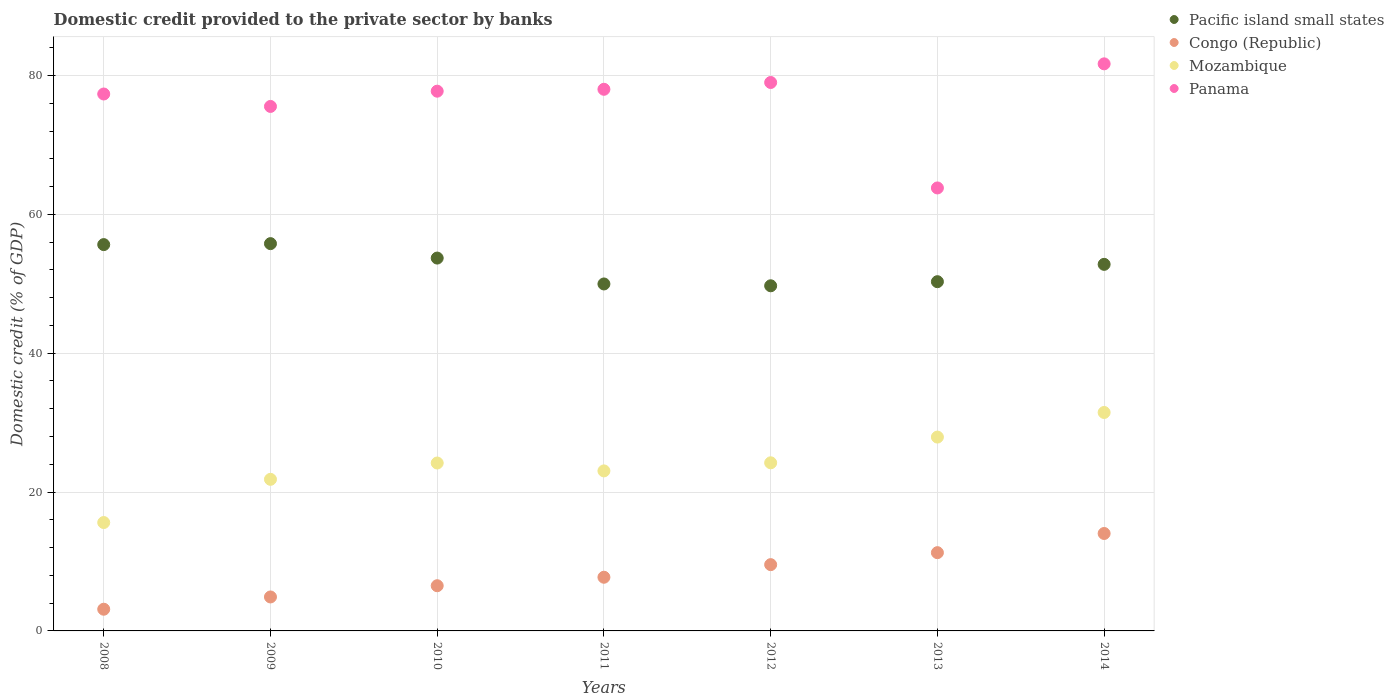How many different coloured dotlines are there?
Provide a short and direct response. 4. Is the number of dotlines equal to the number of legend labels?
Your response must be concise. Yes. What is the domestic credit provided to the private sector by banks in Congo (Republic) in 2010?
Your answer should be very brief. 6.51. Across all years, what is the maximum domestic credit provided to the private sector by banks in Congo (Republic)?
Your answer should be very brief. 14.03. Across all years, what is the minimum domestic credit provided to the private sector by banks in Congo (Republic)?
Your answer should be compact. 3.13. In which year was the domestic credit provided to the private sector by banks in Congo (Republic) maximum?
Offer a very short reply. 2014. In which year was the domestic credit provided to the private sector by banks in Mozambique minimum?
Offer a terse response. 2008. What is the total domestic credit provided to the private sector by banks in Pacific island small states in the graph?
Your answer should be very brief. 367.88. What is the difference between the domestic credit provided to the private sector by banks in Mozambique in 2010 and that in 2013?
Provide a short and direct response. -3.74. What is the difference between the domestic credit provided to the private sector by banks in Panama in 2013 and the domestic credit provided to the private sector by banks in Mozambique in 2008?
Your answer should be compact. 48.19. What is the average domestic credit provided to the private sector by banks in Congo (Republic) per year?
Your answer should be compact. 8.16. In the year 2014, what is the difference between the domestic credit provided to the private sector by banks in Congo (Republic) and domestic credit provided to the private sector by banks in Pacific island small states?
Keep it short and to the point. -38.76. In how many years, is the domestic credit provided to the private sector by banks in Panama greater than 12 %?
Keep it short and to the point. 7. What is the ratio of the domestic credit provided to the private sector by banks in Congo (Republic) in 2010 to that in 2013?
Keep it short and to the point. 0.58. What is the difference between the highest and the second highest domestic credit provided to the private sector by banks in Congo (Republic)?
Offer a terse response. 2.76. What is the difference between the highest and the lowest domestic credit provided to the private sector by banks in Congo (Republic)?
Offer a terse response. 10.91. In how many years, is the domestic credit provided to the private sector by banks in Congo (Republic) greater than the average domestic credit provided to the private sector by banks in Congo (Republic) taken over all years?
Offer a terse response. 3. Is the sum of the domestic credit provided to the private sector by banks in Mozambique in 2011 and 2013 greater than the maximum domestic credit provided to the private sector by banks in Panama across all years?
Keep it short and to the point. No. Is it the case that in every year, the sum of the domestic credit provided to the private sector by banks in Congo (Republic) and domestic credit provided to the private sector by banks in Panama  is greater than the sum of domestic credit provided to the private sector by banks in Pacific island small states and domestic credit provided to the private sector by banks in Mozambique?
Give a very brief answer. No. Does the domestic credit provided to the private sector by banks in Pacific island small states monotonically increase over the years?
Offer a very short reply. No. What is the difference between two consecutive major ticks on the Y-axis?
Provide a short and direct response. 20. Are the values on the major ticks of Y-axis written in scientific E-notation?
Your response must be concise. No. Does the graph contain any zero values?
Provide a short and direct response. No. How are the legend labels stacked?
Ensure brevity in your answer.  Vertical. What is the title of the graph?
Give a very brief answer. Domestic credit provided to the private sector by banks. What is the label or title of the Y-axis?
Provide a succinct answer. Domestic credit (% of GDP). What is the Domestic credit (% of GDP) in Pacific island small states in 2008?
Provide a short and direct response. 55.64. What is the Domestic credit (% of GDP) in Congo (Republic) in 2008?
Offer a very short reply. 3.13. What is the Domestic credit (% of GDP) of Mozambique in 2008?
Keep it short and to the point. 15.61. What is the Domestic credit (% of GDP) in Panama in 2008?
Offer a very short reply. 77.33. What is the Domestic credit (% of GDP) of Pacific island small states in 2009?
Give a very brief answer. 55.78. What is the Domestic credit (% of GDP) in Congo (Republic) in 2009?
Provide a succinct answer. 4.89. What is the Domestic credit (% of GDP) of Mozambique in 2009?
Provide a succinct answer. 21.83. What is the Domestic credit (% of GDP) in Panama in 2009?
Your answer should be compact. 75.54. What is the Domestic credit (% of GDP) of Pacific island small states in 2010?
Your answer should be very brief. 53.7. What is the Domestic credit (% of GDP) in Congo (Republic) in 2010?
Your answer should be very brief. 6.51. What is the Domestic credit (% of GDP) in Mozambique in 2010?
Provide a succinct answer. 24.18. What is the Domestic credit (% of GDP) of Panama in 2010?
Make the answer very short. 77.74. What is the Domestic credit (% of GDP) of Pacific island small states in 2011?
Make the answer very short. 49.97. What is the Domestic credit (% of GDP) in Congo (Republic) in 2011?
Your answer should be very brief. 7.73. What is the Domestic credit (% of GDP) of Mozambique in 2011?
Ensure brevity in your answer.  23.05. What is the Domestic credit (% of GDP) in Panama in 2011?
Offer a very short reply. 78.01. What is the Domestic credit (% of GDP) in Pacific island small states in 2012?
Your answer should be very brief. 49.71. What is the Domestic credit (% of GDP) of Congo (Republic) in 2012?
Ensure brevity in your answer.  9.54. What is the Domestic credit (% of GDP) in Mozambique in 2012?
Provide a short and direct response. 24.21. What is the Domestic credit (% of GDP) of Panama in 2012?
Offer a terse response. 78.99. What is the Domestic credit (% of GDP) of Pacific island small states in 2013?
Make the answer very short. 50.3. What is the Domestic credit (% of GDP) in Congo (Republic) in 2013?
Your answer should be very brief. 11.27. What is the Domestic credit (% of GDP) of Mozambique in 2013?
Provide a succinct answer. 27.92. What is the Domestic credit (% of GDP) in Panama in 2013?
Provide a short and direct response. 63.8. What is the Domestic credit (% of GDP) in Pacific island small states in 2014?
Your answer should be very brief. 52.79. What is the Domestic credit (% of GDP) of Congo (Republic) in 2014?
Make the answer very short. 14.03. What is the Domestic credit (% of GDP) of Mozambique in 2014?
Keep it short and to the point. 31.46. What is the Domestic credit (% of GDP) of Panama in 2014?
Your answer should be very brief. 81.67. Across all years, what is the maximum Domestic credit (% of GDP) of Pacific island small states?
Your answer should be very brief. 55.78. Across all years, what is the maximum Domestic credit (% of GDP) of Congo (Republic)?
Offer a very short reply. 14.03. Across all years, what is the maximum Domestic credit (% of GDP) of Mozambique?
Offer a very short reply. 31.46. Across all years, what is the maximum Domestic credit (% of GDP) of Panama?
Your answer should be very brief. 81.67. Across all years, what is the minimum Domestic credit (% of GDP) in Pacific island small states?
Ensure brevity in your answer.  49.71. Across all years, what is the minimum Domestic credit (% of GDP) of Congo (Republic)?
Give a very brief answer. 3.13. Across all years, what is the minimum Domestic credit (% of GDP) in Mozambique?
Offer a terse response. 15.61. Across all years, what is the minimum Domestic credit (% of GDP) in Panama?
Give a very brief answer. 63.8. What is the total Domestic credit (% of GDP) in Pacific island small states in the graph?
Your response must be concise. 367.88. What is the total Domestic credit (% of GDP) in Congo (Republic) in the graph?
Your answer should be very brief. 57.11. What is the total Domestic credit (% of GDP) in Mozambique in the graph?
Your response must be concise. 168.26. What is the total Domestic credit (% of GDP) of Panama in the graph?
Ensure brevity in your answer.  533.07. What is the difference between the Domestic credit (% of GDP) in Pacific island small states in 2008 and that in 2009?
Offer a terse response. -0.14. What is the difference between the Domestic credit (% of GDP) in Congo (Republic) in 2008 and that in 2009?
Provide a succinct answer. -1.77. What is the difference between the Domestic credit (% of GDP) of Mozambique in 2008 and that in 2009?
Give a very brief answer. -6.22. What is the difference between the Domestic credit (% of GDP) of Panama in 2008 and that in 2009?
Ensure brevity in your answer.  1.79. What is the difference between the Domestic credit (% of GDP) of Pacific island small states in 2008 and that in 2010?
Ensure brevity in your answer.  1.94. What is the difference between the Domestic credit (% of GDP) in Congo (Republic) in 2008 and that in 2010?
Offer a terse response. -3.38. What is the difference between the Domestic credit (% of GDP) of Mozambique in 2008 and that in 2010?
Keep it short and to the point. -8.57. What is the difference between the Domestic credit (% of GDP) in Panama in 2008 and that in 2010?
Provide a short and direct response. -0.41. What is the difference between the Domestic credit (% of GDP) in Pacific island small states in 2008 and that in 2011?
Offer a very short reply. 5.67. What is the difference between the Domestic credit (% of GDP) in Congo (Republic) in 2008 and that in 2011?
Your answer should be compact. -4.61. What is the difference between the Domestic credit (% of GDP) in Mozambique in 2008 and that in 2011?
Your answer should be compact. -7.44. What is the difference between the Domestic credit (% of GDP) of Panama in 2008 and that in 2011?
Your answer should be compact. -0.68. What is the difference between the Domestic credit (% of GDP) of Pacific island small states in 2008 and that in 2012?
Provide a short and direct response. 5.93. What is the difference between the Domestic credit (% of GDP) in Congo (Republic) in 2008 and that in 2012?
Ensure brevity in your answer.  -6.42. What is the difference between the Domestic credit (% of GDP) of Mozambique in 2008 and that in 2012?
Your answer should be very brief. -8.6. What is the difference between the Domestic credit (% of GDP) of Panama in 2008 and that in 2012?
Provide a succinct answer. -1.66. What is the difference between the Domestic credit (% of GDP) in Pacific island small states in 2008 and that in 2013?
Your answer should be very brief. 5.34. What is the difference between the Domestic credit (% of GDP) of Congo (Republic) in 2008 and that in 2013?
Offer a very short reply. -8.15. What is the difference between the Domestic credit (% of GDP) in Mozambique in 2008 and that in 2013?
Provide a short and direct response. -12.31. What is the difference between the Domestic credit (% of GDP) in Panama in 2008 and that in 2013?
Keep it short and to the point. 13.53. What is the difference between the Domestic credit (% of GDP) of Pacific island small states in 2008 and that in 2014?
Give a very brief answer. 2.84. What is the difference between the Domestic credit (% of GDP) in Congo (Republic) in 2008 and that in 2014?
Give a very brief answer. -10.91. What is the difference between the Domestic credit (% of GDP) in Mozambique in 2008 and that in 2014?
Make the answer very short. -15.85. What is the difference between the Domestic credit (% of GDP) in Panama in 2008 and that in 2014?
Your answer should be very brief. -4.34. What is the difference between the Domestic credit (% of GDP) in Pacific island small states in 2009 and that in 2010?
Your response must be concise. 2.08. What is the difference between the Domestic credit (% of GDP) in Congo (Republic) in 2009 and that in 2010?
Your answer should be compact. -1.62. What is the difference between the Domestic credit (% of GDP) in Mozambique in 2009 and that in 2010?
Keep it short and to the point. -2.35. What is the difference between the Domestic credit (% of GDP) in Panama in 2009 and that in 2010?
Make the answer very short. -2.2. What is the difference between the Domestic credit (% of GDP) of Pacific island small states in 2009 and that in 2011?
Provide a succinct answer. 5.81. What is the difference between the Domestic credit (% of GDP) of Congo (Republic) in 2009 and that in 2011?
Provide a short and direct response. -2.84. What is the difference between the Domestic credit (% of GDP) in Mozambique in 2009 and that in 2011?
Offer a very short reply. -1.21. What is the difference between the Domestic credit (% of GDP) in Panama in 2009 and that in 2011?
Offer a terse response. -2.47. What is the difference between the Domestic credit (% of GDP) of Pacific island small states in 2009 and that in 2012?
Offer a terse response. 6.07. What is the difference between the Domestic credit (% of GDP) in Congo (Republic) in 2009 and that in 2012?
Provide a short and direct response. -4.65. What is the difference between the Domestic credit (% of GDP) of Mozambique in 2009 and that in 2012?
Provide a short and direct response. -2.38. What is the difference between the Domestic credit (% of GDP) of Panama in 2009 and that in 2012?
Provide a short and direct response. -3.45. What is the difference between the Domestic credit (% of GDP) in Pacific island small states in 2009 and that in 2013?
Your answer should be compact. 5.48. What is the difference between the Domestic credit (% of GDP) in Congo (Republic) in 2009 and that in 2013?
Keep it short and to the point. -6.38. What is the difference between the Domestic credit (% of GDP) in Mozambique in 2009 and that in 2013?
Your answer should be very brief. -6.09. What is the difference between the Domestic credit (% of GDP) of Panama in 2009 and that in 2013?
Keep it short and to the point. 11.74. What is the difference between the Domestic credit (% of GDP) of Pacific island small states in 2009 and that in 2014?
Your response must be concise. 2.98. What is the difference between the Domestic credit (% of GDP) of Congo (Republic) in 2009 and that in 2014?
Your answer should be compact. -9.14. What is the difference between the Domestic credit (% of GDP) of Mozambique in 2009 and that in 2014?
Provide a succinct answer. -9.63. What is the difference between the Domestic credit (% of GDP) in Panama in 2009 and that in 2014?
Provide a short and direct response. -6.13. What is the difference between the Domestic credit (% of GDP) of Pacific island small states in 2010 and that in 2011?
Offer a very short reply. 3.73. What is the difference between the Domestic credit (% of GDP) of Congo (Republic) in 2010 and that in 2011?
Offer a terse response. -1.22. What is the difference between the Domestic credit (% of GDP) of Mozambique in 2010 and that in 2011?
Provide a short and direct response. 1.14. What is the difference between the Domestic credit (% of GDP) in Panama in 2010 and that in 2011?
Your answer should be very brief. -0.27. What is the difference between the Domestic credit (% of GDP) in Pacific island small states in 2010 and that in 2012?
Keep it short and to the point. 3.99. What is the difference between the Domestic credit (% of GDP) in Congo (Republic) in 2010 and that in 2012?
Make the answer very short. -3.04. What is the difference between the Domestic credit (% of GDP) of Mozambique in 2010 and that in 2012?
Your answer should be compact. -0.03. What is the difference between the Domestic credit (% of GDP) in Panama in 2010 and that in 2012?
Keep it short and to the point. -1.25. What is the difference between the Domestic credit (% of GDP) of Pacific island small states in 2010 and that in 2013?
Ensure brevity in your answer.  3.4. What is the difference between the Domestic credit (% of GDP) in Congo (Republic) in 2010 and that in 2013?
Offer a terse response. -4.76. What is the difference between the Domestic credit (% of GDP) of Mozambique in 2010 and that in 2013?
Offer a very short reply. -3.74. What is the difference between the Domestic credit (% of GDP) in Panama in 2010 and that in 2013?
Keep it short and to the point. 13.94. What is the difference between the Domestic credit (% of GDP) in Pacific island small states in 2010 and that in 2014?
Your response must be concise. 0.91. What is the difference between the Domestic credit (% of GDP) of Congo (Republic) in 2010 and that in 2014?
Provide a short and direct response. -7.52. What is the difference between the Domestic credit (% of GDP) in Mozambique in 2010 and that in 2014?
Keep it short and to the point. -7.28. What is the difference between the Domestic credit (% of GDP) of Panama in 2010 and that in 2014?
Offer a very short reply. -3.94. What is the difference between the Domestic credit (% of GDP) of Pacific island small states in 2011 and that in 2012?
Keep it short and to the point. 0.26. What is the difference between the Domestic credit (% of GDP) in Congo (Republic) in 2011 and that in 2012?
Give a very brief answer. -1.81. What is the difference between the Domestic credit (% of GDP) in Mozambique in 2011 and that in 2012?
Your answer should be very brief. -1.17. What is the difference between the Domestic credit (% of GDP) in Panama in 2011 and that in 2012?
Provide a succinct answer. -0.98. What is the difference between the Domestic credit (% of GDP) of Pacific island small states in 2011 and that in 2013?
Provide a succinct answer. -0.33. What is the difference between the Domestic credit (% of GDP) in Congo (Republic) in 2011 and that in 2013?
Make the answer very short. -3.54. What is the difference between the Domestic credit (% of GDP) in Mozambique in 2011 and that in 2013?
Your answer should be compact. -4.87. What is the difference between the Domestic credit (% of GDP) of Panama in 2011 and that in 2013?
Your response must be concise. 14.21. What is the difference between the Domestic credit (% of GDP) in Pacific island small states in 2011 and that in 2014?
Your answer should be very brief. -2.82. What is the difference between the Domestic credit (% of GDP) of Congo (Republic) in 2011 and that in 2014?
Offer a very short reply. -6.3. What is the difference between the Domestic credit (% of GDP) of Mozambique in 2011 and that in 2014?
Keep it short and to the point. -8.41. What is the difference between the Domestic credit (% of GDP) of Panama in 2011 and that in 2014?
Provide a succinct answer. -3.67. What is the difference between the Domestic credit (% of GDP) of Pacific island small states in 2012 and that in 2013?
Your response must be concise. -0.59. What is the difference between the Domestic credit (% of GDP) of Congo (Republic) in 2012 and that in 2013?
Offer a terse response. -1.73. What is the difference between the Domestic credit (% of GDP) in Mozambique in 2012 and that in 2013?
Your answer should be very brief. -3.71. What is the difference between the Domestic credit (% of GDP) in Panama in 2012 and that in 2013?
Keep it short and to the point. 15.19. What is the difference between the Domestic credit (% of GDP) in Pacific island small states in 2012 and that in 2014?
Your answer should be very brief. -3.09. What is the difference between the Domestic credit (% of GDP) in Congo (Republic) in 2012 and that in 2014?
Keep it short and to the point. -4.49. What is the difference between the Domestic credit (% of GDP) of Mozambique in 2012 and that in 2014?
Your answer should be compact. -7.25. What is the difference between the Domestic credit (% of GDP) of Panama in 2012 and that in 2014?
Offer a very short reply. -2.69. What is the difference between the Domestic credit (% of GDP) of Pacific island small states in 2013 and that in 2014?
Your answer should be compact. -2.5. What is the difference between the Domestic credit (% of GDP) in Congo (Republic) in 2013 and that in 2014?
Give a very brief answer. -2.76. What is the difference between the Domestic credit (% of GDP) of Mozambique in 2013 and that in 2014?
Give a very brief answer. -3.54. What is the difference between the Domestic credit (% of GDP) of Panama in 2013 and that in 2014?
Ensure brevity in your answer.  -17.87. What is the difference between the Domestic credit (% of GDP) of Pacific island small states in 2008 and the Domestic credit (% of GDP) of Congo (Republic) in 2009?
Your response must be concise. 50.75. What is the difference between the Domestic credit (% of GDP) of Pacific island small states in 2008 and the Domestic credit (% of GDP) of Mozambique in 2009?
Give a very brief answer. 33.81. What is the difference between the Domestic credit (% of GDP) in Pacific island small states in 2008 and the Domestic credit (% of GDP) in Panama in 2009?
Offer a very short reply. -19.9. What is the difference between the Domestic credit (% of GDP) of Congo (Republic) in 2008 and the Domestic credit (% of GDP) of Mozambique in 2009?
Offer a very short reply. -18.71. What is the difference between the Domestic credit (% of GDP) of Congo (Republic) in 2008 and the Domestic credit (% of GDP) of Panama in 2009?
Your answer should be very brief. -72.41. What is the difference between the Domestic credit (% of GDP) in Mozambique in 2008 and the Domestic credit (% of GDP) in Panama in 2009?
Give a very brief answer. -59.93. What is the difference between the Domestic credit (% of GDP) of Pacific island small states in 2008 and the Domestic credit (% of GDP) of Congo (Republic) in 2010?
Ensure brevity in your answer.  49.13. What is the difference between the Domestic credit (% of GDP) of Pacific island small states in 2008 and the Domestic credit (% of GDP) of Mozambique in 2010?
Provide a short and direct response. 31.46. What is the difference between the Domestic credit (% of GDP) of Pacific island small states in 2008 and the Domestic credit (% of GDP) of Panama in 2010?
Your response must be concise. -22.1. What is the difference between the Domestic credit (% of GDP) in Congo (Republic) in 2008 and the Domestic credit (% of GDP) in Mozambique in 2010?
Your answer should be compact. -21.06. What is the difference between the Domestic credit (% of GDP) of Congo (Republic) in 2008 and the Domestic credit (% of GDP) of Panama in 2010?
Make the answer very short. -74.61. What is the difference between the Domestic credit (% of GDP) of Mozambique in 2008 and the Domestic credit (% of GDP) of Panama in 2010?
Provide a short and direct response. -62.13. What is the difference between the Domestic credit (% of GDP) of Pacific island small states in 2008 and the Domestic credit (% of GDP) of Congo (Republic) in 2011?
Keep it short and to the point. 47.91. What is the difference between the Domestic credit (% of GDP) in Pacific island small states in 2008 and the Domestic credit (% of GDP) in Mozambique in 2011?
Keep it short and to the point. 32.59. What is the difference between the Domestic credit (% of GDP) in Pacific island small states in 2008 and the Domestic credit (% of GDP) in Panama in 2011?
Make the answer very short. -22.37. What is the difference between the Domestic credit (% of GDP) in Congo (Republic) in 2008 and the Domestic credit (% of GDP) in Mozambique in 2011?
Offer a very short reply. -19.92. What is the difference between the Domestic credit (% of GDP) of Congo (Republic) in 2008 and the Domestic credit (% of GDP) of Panama in 2011?
Your answer should be very brief. -74.88. What is the difference between the Domestic credit (% of GDP) of Mozambique in 2008 and the Domestic credit (% of GDP) of Panama in 2011?
Your answer should be compact. -62.4. What is the difference between the Domestic credit (% of GDP) of Pacific island small states in 2008 and the Domestic credit (% of GDP) of Congo (Republic) in 2012?
Offer a very short reply. 46.09. What is the difference between the Domestic credit (% of GDP) of Pacific island small states in 2008 and the Domestic credit (% of GDP) of Mozambique in 2012?
Provide a short and direct response. 31.43. What is the difference between the Domestic credit (% of GDP) of Pacific island small states in 2008 and the Domestic credit (% of GDP) of Panama in 2012?
Your response must be concise. -23.35. What is the difference between the Domestic credit (% of GDP) of Congo (Republic) in 2008 and the Domestic credit (% of GDP) of Mozambique in 2012?
Ensure brevity in your answer.  -21.09. What is the difference between the Domestic credit (% of GDP) in Congo (Republic) in 2008 and the Domestic credit (% of GDP) in Panama in 2012?
Your response must be concise. -75.86. What is the difference between the Domestic credit (% of GDP) in Mozambique in 2008 and the Domestic credit (% of GDP) in Panama in 2012?
Offer a terse response. -63.38. What is the difference between the Domestic credit (% of GDP) in Pacific island small states in 2008 and the Domestic credit (% of GDP) in Congo (Republic) in 2013?
Provide a succinct answer. 44.37. What is the difference between the Domestic credit (% of GDP) in Pacific island small states in 2008 and the Domestic credit (% of GDP) in Mozambique in 2013?
Keep it short and to the point. 27.72. What is the difference between the Domestic credit (% of GDP) in Pacific island small states in 2008 and the Domestic credit (% of GDP) in Panama in 2013?
Provide a succinct answer. -8.16. What is the difference between the Domestic credit (% of GDP) in Congo (Republic) in 2008 and the Domestic credit (% of GDP) in Mozambique in 2013?
Your response must be concise. -24.79. What is the difference between the Domestic credit (% of GDP) in Congo (Republic) in 2008 and the Domestic credit (% of GDP) in Panama in 2013?
Make the answer very short. -60.67. What is the difference between the Domestic credit (% of GDP) in Mozambique in 2008 and the Domestic credit (% of GDP) in Panama in 2013?
Your answer should be compact. -48.19. What is the difference between the Domestic credit (% of GDP) in Pacific island small states in 2008 and the Domestic credit (% of GDP) in Congo (Republic) in 2014?
Keep it short and to the point. 41.61. What is the difference between the Domestic credit (% of GDP) in Pacific island small states in 2008 and the Domestic credit (% of GDP) in Mozambique in 2014?
Make the answer very short. 24.18. What is the difference between the Domestic credit (% of GDP) of Pacific island small states in 2008 and the Domestic credit (% of GDP) of Panama in 2014?
Provide a succinct answer. -26.03. What is the difference between the Domestic credit (% of GDP) of Congo (Republic) in 2008 and the Domestic credit (% of GDP) of Mozambique in 2014?
Your response must be concise. -28.34. What is the difference between the Domestic credit (% of GDP) in Congo (Republic) in 2008 and the Domestic credit (% of GDP) in Panama in 2014?
Provide a succinct answer. -78.55. What is the difference between the Domestic credit (% of GDP) of Mozambique in 2008 and the Domestic credit (% of GDP) of Panama in 2014?
Provide a short and direct response. -66.06. What is the difference between the Domestic credit (% of GDP) of Pacific island small states in 2009 and the Domestic credit (% of GDP) of Congo (Republic) in 2010?
Provide a short and direct response. 49.27. What is the difference between the Domestic credit (% of GDP) in Pacific island small states in 2009 and the Domestic credit (% of GDP) in Mozambique in 2010?
Keep it short and to the point. 31.6. What is the difference between the Domestic credit (% of GDP) in Pacific island small states in 2009 and the Domestic credit (% of GDP) in Panama in 2010?
Your response must be concise. -21.96. What is the difference between the Domestic credit (% of GDP) of Congo (Republic) in 2009 and the Domestic credit (% of GDP) of Mozambique in 2010?
Offer a terse response. -19.29. What is the difference between the Domestic credit (% of GDP) of Congo (Republic) in 2009 and the Domestic credit (% of GDP) of Panama in 2010?
Make the answer very short. -72.84. What is the difference between the Domestic credit (% of GDP) of Mozambique in 2009 and the Domestic credit (% of GDP) of Panama in 2010?
Make the answer very short. -55.9. What is the difference between the Domestic credit (% of GDP) of Pacific island small states in 2009 and the Domestic credit (% of GDP) of Congo (Republic) in 2011?
Your answer should be very brief. 48.05. What is the difference between the Domestic credit (% of GDP) in Pacific island small states in 2009 and the Domestic credit (% of GDP) in Mozambique in 2011?
Ensure brevity in your answer.  32.73. What is the difference between the Domestic credit (% of GDP) in Pacific island small states in 2009 and the Domestic credit (% of GDP) in Panama in 2011?
Offer a very short reply. -22.23. What is the difference between the Domestic credit (% of GDP) in Congo (Republic) in 2009 and the Domestic credit (% of GDP) in Mozambique in 2011?
Make the answer very short. -18.15. What is the difference between the Domestic credit (% of GDP) in Congo (Republic) in 2009 and the Domestic credit (% of GDP) in Panama in 2011?
Keep it short and to the point. -73.11. What is the difference between the Domestic credit (% of GDP) in Mozambique in 2009 and the Domestic credit (% of GDP) in Panama in 2011?
Make the answer very short. -56.17. What is the difference between the Domestic credit (% of GDP) of Pacific island small states in 2009 and the Domestic credit (% of GDP) of Congo (Republic) in 2012?
Offer a very short reply. 46.23. What is the difference between the Domestic credit (% of GDP) in Pacific island small states in 2009 and the Domestic credit (% of GDP) in Mozambique in 2012?
Make the answer very short. 31.57. What is the difference between the Domestic credit (% of GDP) in Pacific island small states in 2009 and the Domestic credit (% of GDP) in Panama in 2012?
Give a very brief answer. -23.21. What is the difference between the Domestic credit (% of GDP) of Congo (Republic) in 2009 and the Domestic credit (% of GDP) of Mozambique in 2012?
Keep it short and to the point. -19.32. What is the difference between the Domestic credit (% of GDP) in Congo (Republic) in 2009 and the Domestic credit (% of GDP) in Panama in 2012?
Keep it short and to the point. -74.09. What is the difference between the Domestic credit (% of GDP) of Mozambique in 2009 and the Domestic credit (% of GDP) of Panama in 2012?
Offer a very short reply. -57.15. What is the difference between the Domestic credit (% of GDP) of Pacific island small states in 2009 and the Domestic credit (% of GDP) of Congo (Republic) in 2013?
Give a very brief answer. 44.51. What is the difference between the Domestic credit (% of GDP) in Pacific island small states in 2009 and the Domestic credit (% of GDP) in Mozambique in 2013?
Your answer should be very brief. 27.86. What is the difference between the Domestic credit (% of GDP) in Pacific island small states in 2009 and the Domestic credit (% of GDP) in Panama in 2013?
Offer a very short reply. -8.02. What is the difference between the Domestic credit (% of GDP) in Congo (Republic) in 2009 and the Domestic credit (% of GDP) in Mozambique in 2013?
Ensure brevity in your answer.  -23.03. What is the difference between the Domestic credit (% of GDP) of Congo (Republic) in 2009 and the Domestic credit (% of GDP) of Panama in 2013?
Ensure brevity in your answer.  -58.91. What is the difference between the Domestic credit (% of GDP) of Mozambique in 2009 and the Domestic credit (% of GDP) of Panama in 2013?
Your answer should be very brief. -41.97. What is the difference between the Domestic credit (% of GDP) in Pacific island small states in 2009 and the Domestic credit (% of GDP) in Congo (Republic) in 2014?
Provide a short and direct response. 41.75. What is the difference between the Domestic credit (% of GDP) of Pacific island small states in 2009 and the Domestic credit (% of GDP) of Mozambique in 2014?
Offer a very short reply. 24.32. What is the difference between the Domestic credit (% of GDP) in Pacific island small states in 2009 and the Domestic credit (% of GDP) in Panama in 2014?
Keep it short and to the point. -25.89. What is the difference between the Domestic credit (% of GDP) in Congo (Republic) in 2009 and the Domestic credit (% of GDP) in Mozambique in 2014?
Offer a very short reply. -26.57. What is the difference between the Domestic credit (% of GDP) of Congo (Republic) in 2009 and the Domestic credit (% of GDP) of Panama in 2014?
Ensure brevity in your answer.  -76.78. What is the difference between the Domestic credit (% of GDP) of Mozambique in 2009 and the Domestic credit (% of GDP) of Panama in 2014?
Your answer should be very brief. -59.84. What is the difference between the Domestic credit (% of GDP) in Pacific island small states in 2010 and the Domestic credit (% of GDP) in Congo (Republic) in 2011?
Give a very brief answer. 45.97. What is the difference between the Domestic credit (% of GDP) of Pacific island small states in 2010 and the Domestic credit (% of GDP) of Mozambique in 2011?
Provide a short and direct response. 30.65. What is the difference between the Domestic credit (% of GDP) in Pacific island small states in 2010 and the Domestic credit (% of GDP) in Panama in 2011?
Ensure brevity in your answer.  -24.31. What is the difference between the Domestic credit (% of GDP) in Congo (Republic) in 2010 and the Domestic credit (% of GDP) in Mozambique in 2011?
Your answer should be very brief. -16.54. What is the difference between the Domestic credit (% of GDP) in Congo (Republic) in 2010 and the Domestic credit (% of GDP) in Panama in 2011?
Provide a short and direct response. -71.5. What is the difference between the Domestic credit (% of GDP) of Mozambique in 2010 and the Domestic credit (% of GDP) of Panama in 2011?
Keep it short and to the point. -53.82. What is the difference between the Domestic credit (% of GDP) in Pacific island small states in 2010 and the Domestic credit (% of GDP) in Congo (Republic) in 2012?
Provide a short and direct response. 44.15. What is the difference between the Domestic credit (% of GDP) of Pacific island small states in 2010 and the Domestic credit (% of GDP) of Mozambique in 2012?
Ensure brevity in your answer.  29.49. What is the difference between the Domestic credit (% of GDP) in Pacific island small states in 2010 and the Domestic credit (% of GDP) in Panama in 2012?
Give a very brief answer. -25.29. What is the difference between the Domestic credit (% of GDP) of Congo (Republic) in 2010 and the Domestic credit (% of GDP) of Mozambique in 2012?
Give a very brief answer. -17.7. What is the difference between the Domestic credit (% of GDP) of Congo (Republic) in 2010 and the Domestic credit (% of GDP) of Panama in 2012?
Ensure brevity in your answer.  -72.48. What is the difference between the Domestic credit (% of GDP) of Mozambique in 2010 and the Domestic credit (% of GDP) of Panama in 2012?
Provide a short and direct response. -54.8. What is the difference between the Domestic credit (% of GDP) in Pacific island small states in 2010 and the Domestic credit (% of GDP) in Congo (Republic) in 2013?
Your answer should be very brief. 42.43. What is the difference between the Domestic credit (% of GDP) of Pacific island small states in 2010 and the Domestic credit (% of GDP) of Mozambique in 2013?
Your answer should be very brief. 25.78. What is the difference between the Domestic credit (% of GDP) of Pacific island small states in 2010 and the Domestic credit (% of GDP) of Panama in 2013?
Make the answer very short. -10.1. What is the difference between the Domestic credit (% of GDP) of Congo (Republic) in 2010 and the Domestic credit (% of GDP) of Mozambique in 2013?
Provide a succinct answer. -21.41. What is the difference between the Domestic credit (% of GDP) of Congo (Republic) in 2010 and the Domestic credit (% of GDP) of Panama in 2013?
Make the answer very short. -57.29. What is the difference between the Domestic credit (% of GDP) of Mozambique in 2010 and the Domestic credit (% of GDP) of Panama in 2013?
Ensure brevity in your answer.  -39.62. What is the difference between the Domestic credit (% of GDP) in Pacific island small states in 2010 and the Domestic credit (% of GDP) in Congo (Republic) in 2014?
Keep it short and to the point. 39.67. What is the difference between the Domestic credit (% of GDP) of Pacific island small states in 2010 and the Domestic credit (% of GDP) of Mozambique in 2014?
Give a very brief answer. 22.24. What is the difference between the Domestic credit (% of GDP) of Pacific island small states in 2010 and the Domestic credit (% of GDP) of Panama in 2014?
Provide a short and direct response. -27.97. What is the difference between the Domestic credit (% of GDP) of Congo (Republic) in 2010 and the Domestic credit (% of GDP) of Mozambique in 2014?
Make the answer very short. -24.95. What is the difference between the Domestic credit (% of GDP) of Congo (Republic) in 2010 and the Domestic credit (% of GDP) of Panama in 2014?
Offer a terse response. -75.16. What is the difference between the Domestic credit (% of GDP) of Mozambique in 2010 and the Domestic credit (% of GDP) of Panama in 2014?
Offer a very short reply. -57.49. What is the difference between the Domestic credit (% of GDP) in Pacific island small states in 2011 and the Domestic credit (% of GDP) in Congo (Republic) in 2012?
Provide a short and direct response. 40.43. What is the difference between the Domestic credit (% of GDP) in Pacific island small states in 2011 and the Domestic credit (% of GDP) in Mozambique in 2012?
Keep it short and to the point. 25.76. What is the difference between the Domestic credit (% of GDP) in Pacific island small states in 2011 and the Domestic credit (% of GDP) in Panama in 2012?
Your answer should be very brief. -29.02. What is the difference between the Domestic credit (% of GDP) in Congo (Republic) in 2011 and the Domestic credit (% of GDP) in Mozambique in 2012?
Ensure brevity in your answer.  -16.48. What is the difference between the Domestic credit (% of GDP) of Congo (Republic) in 2011 and the Domestic credit (% of GDP) of Panama in 2012?
Keep it short and to the point. -71.26. What is the difference between the Domestic credit (% of GDP) in Mozambique in 2011 and the Domestic credit (% of GDP) in Panama in 2012?
Ensure brevity in your answer.  -55.94. What is the difference between the Domestic credit (% of GDP) of Pacific island small states in 2011 and the Domestic credit (% of GDP) of Congo (Republic) in 2013?
Offer a very short reply. 38.7. What is the difference between the Domestic credit (% of GDP) of Pacific island small states in 2011 and the Domestic credit (% of GDP) of Mozambique in 2013?
Offer a terse response. 22.05. What is the difference between the Domestic credit (% of GDP) of Pacific island small states in 2011 and the Domestic credit (% of GDP) of Panama in 2013?
Ensure brevity in your answer.  -13.83. What is the difference between the Domestic credit (% of GDP) in Congo (Republic) in 2011 and the Domestic credit (% of GDP) in Mozambique in 2013?
Make the answer very short. -20.19. What is the difference between the Domestic credit (% of GDP) of Congo (Republic) in 2011 and the Domestic credit (% of GDP) of Panama in 2013?
Your answer should be compact. -56.07. What is the difference between the Domestic credit (% of GDP) of Mozambique in 2011 and the Domestic credit (% of GDP) of Panama in 2013?
Ensure brevity in your answer.  -40.75. What is the difference between the Domestic credit (% of GDP) in Pacific island small states in 2011 and the Domestic credit (% of GDP) in Congo (Republic) in 2014?
Provide a short and direct response. 35.94. What is the difference between the Domestic credit (% of GDP) in Pacific island small states in 2011 and the Domestic credit (% of GDP) in Mozambique in 2014?
Offer a terse response. 18.51. What is the difference between the Domestic credit (% of GDP) of Pacific island small states in 2011 and the Domestic credit (% of GDP) of Panama in 2014?
Provide a short and direct response. -31.7. What is the difference between the Domestic credit (% of GDP) of Congo (Republic) in 2011 and the Domestic credit (% of GDP) of Mozambique in 2014?
Your answer should be compact. -23.73. What is the difference between the Domestic credit (% of GDP) in Congo (Republic) in 2011 and the Domestic credit (% of GDP) in Panama in 2014?
Keep it short and to the point. -73.94. What is the difference between the Domestic credit (% of GDP) in Mozambique in 2011 and the Domestic credit (% of GDP) in Panama in 2014?
Ensure brevity in your answer.  -58.63. What is the difference between the Domestic credit (% of GDP) of Pacific island small states in 2012 and the Domestic credit (% of GDP) of Congo (Republic) in 2013?
Make the answer very short. 38.44. What is the difference between the Domestic credit (% of GDP) in Pacific island small states in 2012 and the Domestic credit (% of GDP) in Mozambique in 2013?
Give a very brief answer. 21.79. What is the difference between the Domestic credit (% of GDP) in Pacific island small states in 2012 and the Domestic credit (% of GDP) in Panama in 2013?
Provide a short and direct response. -14.09. What is the difference between the Domestic credit (% of GDP) in Congo (Republic) in 2012 and the Domestic credit (% of GDP) in Mozambique in 2013?
Offer a very short reply. -18.37. What is the difference between the Domestic credit (% of GDP) of Congo (Republic) in 2012 and the Domestic credit (% of GDP) of Panama in 2013?
Your response must be concise. -54.25. What is the difference between the Domestic credit (% of GDP) in Mozambique in 2012 and the Domestic credit (% of GDP) in Panama in 2013?
Your response must be concise. -39.59. What is the difference between the Domestic credit (% of GDP) of Pacific island small states in 2012 and the Domestic credit (% of GDP) of Congo (Republic) in 2014?
Ensure brevity in your answer.  35.67. What is the difference between the Domestic credit (% of GDP) of Pacific island small states in 2012 and the Domestic credit (% of GDP) of Mozambique in 2014?
Offer a terse response. 18.25. What is the difference between the Domestic credit (% of GDP) of Pacific island small states in 2012 and the Domestic credit (% of GDP) of Panama in 2014?
Provide a short and direct response. -31.97. What is the difference between the Domestic credit (% of GDP) in Congo (Republic) in 2012 and the Domestic credit (% of GDP) in Mozambique in 2014?
Your answer should be compact. -21.92. What is the difference between the Domestic credit (% of GDP) in Congo (Republic) in 2012 and the Domestic credit (% of GDP) in Panama in 2014?
Give a very brief answer. -72.13. What is the difference between the Domestic credit (% of GDP) in Mozambique in 2012 and the Domestic credit (% of GDP) in Panama in 2014?
Make the answer very short. -57.46. What is the difference between the Domestic credit (% of GDP) of Pacific island small states in 2013 and the Domestic credit (% of GDP) of Congo (Republic) in 2014?
Make the answer very short. 36.26. What is the difference between the Domestic credit (% of GDP) of Pacific island small states in 2013 and the Domestic credit (% of GDP) of Mozambique in 2014?
Give a very brief answer. 18.84. What is the difference between the Domestic credit (% of GDP) in Pacific island small states in 2013 and the Domestic credit (% of GDP) in Panama in 2014?
Ensure brevity in your answer.  -31.37. What is the difference between the Domestic credit (% of GDP) of Congo (Republic) in 2013 and the Domestic credit (% of GDP) of Mozambique in 2014?
Provide a succinct answer. -20.19. What is the difference between the Domestic credit (% of GDP) in Congo (Republic) in 2013 and the Domestic credit (% of GDP) in Panama in 2014?
Provide a succinct answer. -70.4. What is the difference between the Domestic credit (% of GDP) of Mozambique in 2013 and the Domestic credit (% of GDP) of Panama in 2014?
Your answer should be very brief. -53.75. What is the average Domestic credit (% of GDP) in Pacific island small states per year?
Provide a succinct answer. 52.55. What is the average Domestic credit (% of GDP) of Congo (Republic) per year?
Provide a succinct answer. 8.16. What is the average Domestic credit (% of GDP) of Mozambique per year?
Your answer should be compact. 24.04. What is the average Domestic credit (% of GDP) in Panama per year?
Offer a terse response. 76.15. In the year 2008, what is the difference between the Domestic credit (% of GDP) of Pacific island small states and Domestic credit (% of GDP) of Congo (Republic)?
Keep it short and to the point. 52.51. In the year 2008, what is the difference between the Domestic credit (% of GDP) of Pacific island small states and Domestic credit (% of GDP) of Mozambique?
Give a very brief answer. 40.03. In the year 2008, what is the difference between the Domestic credit (% of GDP) in Pacific island small states and Domestic credit (% of GDP) in Panama?
Offer a terse response. -21.69. In the year 2008, what is the difference between the Domestic credit (% of GDP) of Congo (Republic) and Domestic credit (% of GDP) of Mozambique?
Your answer should be compact. -12.49. In the year 2008, what is the difference between the Domestic credit (% of GDP) in Congo (Republic) and Domestic credit (% of GDP) in Panama?
Ensure brevity in your answer.  -74.2. In the year 2008, what is the difference between the Domestic credit (% of GDP) in Mozambique and Domestic credit (% of GDP) in Panama?
Provide a short and direct response. -61.72. In the year 2009, what is the difference between the Domestic credit (% of GDP) of Pacific island small states and Domestic credit (% of GDP) of Congo (Republic)?
Give a very brief answer. 50.89. In the year 2009, what is the difference between the Domestic credit (% of GDP) in Pacific island small states and Domestic credit (% of GDP) in Mozambique?
Your answer should be very brief. 33.95. In the year 2009, what is the difference between the Domestic credit (% of GDP) of Pacific island small states and Domestic credit (% of GDP) of Panama?
Keep it short and to the point. -19.76. In the year 2009, what is the difference between the Domestic credit (% of GDP) of Congo (Republic) and Domestic credit (% of GDP) of Mozambique?
Provide a succinct answer. -16.94. In the year 2009, what is the difference between the Domestic credit (% of GDP) in Congo (Republic) and Domestic credit (% of GDP) in Panama?
Give a very brief answer. -70.65. In the year 2009, what is the difference between the Domestic credit (% of GDP) of Mozambique and Domestic credit (% of GDP) of Panama?
Ensure brevity in your answer.  -53.71. In the year 2010, what is the difference between the Domestic credit (% of GDP) of Pacific island small states and Domestic credit (% of GDP) of Congo (Republic)?
Give a very brief answer. 47.19. In the year 2010, what is the difference between the Domestic credit (% of GDP) in Pacific island small states and Domestic credit (% of GDP) in Mozambique?
Keep it short and to the point. 29.52. In the year 2010, what is the difference between the Domestic credit (% of GDP) of Pacific island small states and Domestic credit (% of GDP) of Panama?
Your answer should be very brief. -24.04. In the year 2010, what is the difference between the Domestic credit (% of GDP) in Congo (Republic) and Domestic credit (% of GDP) in Mozambique?
Ensure brevity in your answer.  -17.67. In the year 2010, what is the difference between the Domestic credit (% of GDP) of Congo (Republic) and Domestic credit (% of GDP) of Panama?
Offer a very short reply. -71.23. In the year 2010, what is the difference between the Domestic credit (% of GDP) in Mozambique and Domestic credit (% of GDP) in Panama?
Provide a short and direct response. -53.55. In the year 2011, what is the difference between the Domestic credit (% of GDP) of Pacific island small states and Domestic credit (% of GDP) of Congo (Republic)?
Ensure brevity in your answer.  42.24. In the year 2011, what is the difference between the Domestic credit (% of GDP) of Pacific island small states and Domestic credit (% of GDP) of Mozambique?
Offer a terse response. 26.92. In the year 2011, what is the difference between the Domestic credit (% of GDP) of Pacific island small states and Domestic credit (% of GDP) of Panama?
Offer a terse response. -28.04. In the year 2011, what is the difference between the Domestic credit (% of GDP) of Congo (Republic) and Domestic credit (% of GDP) of Mozambique?
Provide a succinct answer. -15.32. In the year 2011, what is the difference between the Domestic credit (% of GDP) in Congo (Republic) and Domestic credit (% of GDP) in Panama?
Ensure brevity in your answer.  -70.28. In the year 2011, what is the difference between the Domestic credit (% of GDP) of Mozambique and Domestic credit (% of GDP) of Panama?
Keep it short and to the point. -54.96. In the year 2012, what is the difference between the Domestic credit (% of GDP) of Pacific island small states and Domestic credit (% of GDP) of Congo (Republic)?
Provide a succinct answer. 40.16. In the year 2012, what is the difference between the Domestic credit (% of GDP) of Pacific island small states and Domestic credit (% of GDP) of Mozambique?
Offer a terse response. 25.49. In the year 2012, what is the difference between the Domestic credit (% of GDP) of Pacific island small states and Domestic credit (% of GDP) of Panama?
Make the answer very short. -29.28. In the year 2012, what is the difference between the Domestic credit (% of GDP) in Congo (Republic) and Domestic credit (% of GDP) in Mozambique?
Offer a terse response. -14.67. In the year 2012, what is the difference between the Domestic credit (% of GDP) in Congo (Republic) and Domestic credit (% of GDP) in Panama?
Your answer should be compact. -69.44. In the year 2012, what is the difference between the Domestic credit (% of GDP) of Mozambique and Domestic credit (% of GDP) of Panama?
Provide a short and direct response. -54.77. In the year 2013, what is the difference between the Domestic credit (% of GDP) of Pacific island small states and Domestic credit (% of GDP) of Congo (Republic)?
Ensure brevity in your answer.  39.03. In the year 2013, what is the difference between the Domestic credit (% of GDP) in Pacific island small states and Domestic credit (% of GDP) in Mozambique?
Ensure brevity in your answer.  22.38. In the year 2013, what is the difference between the Domestic credit (% of GDP) of Pacific island small states and Domestic credit (% of GDP) of Panama?
Keep it short and to the point. -13.5. In the year 2013, what is the difference between the Domestic credit (% of GDP) of Congo (Republic) and Domestic credit (% of GDP) of Mozambique?
Offer a terse response. -16.65. In the year 2013, what is the difference between the Domestic credit (% of GDP) of Congo (Republic) and Domestic credit (% of GDP) of Panama?
Your answer should be very brief. -52.53. In the year 2013, what is the difference between the Domestic credit (% of GDP) in Mozambique and Domestic credit (% of GDP) in Panama?
Give a very brief answer. -35.88. In the year 2014, what is the difference between the Domestic credit (% of GDP) in Pacific island small states and Domestic credit (% of GDP) in Congo (Republic)?
Your answer should be very brief. 38.76. In the year 2014, what is the difference between the Domestic credit (% of GDP) in Pacific island small states and Domestic credit (% of GDP) in Mozambique?
Make the answer very short. 21.33. In the year 2014, what is the difference between the Domestic credit (% of GDP) in Pacific island small states and Domestic credit (% of GDP) in Panama?
Your answer should be very brief. -28.88. In the year 2014, what is the difference between the Domestic credit (% of GDP) in Congo (Republic) and Domestic credit (% of GDP) in Mozambique?
Your answer should be very brief. -17.43. In the year 2014, what is the difference between the Domestic credit (% of GDP) in Congo (Republic) and Domestic credit (% of GDP) in Panama?
Your answer should be very brief. -67.64. In the year 2014, what is the difference between the Domestic credit (% of GDP) in Mozambique and Domestic credit (% of GDP) in Panama?
Offer a very short reply. -50.21. What is the ratio of the Domestic credit (% of GDP) of Congo (Republic) in 2008 to that in 2009?
Your answer should be compact. 0.64. What is the ratio of the Domestic credit (% of GDP) of Mozambique in 2008 to that in 2009?
Provide a succinct answer. 0.71. What is the ratio of the Domestic credit (% of GDP) of Panama in 2008 to that in 2009?
Provide a succinct answer. 1.02. What is the ratio of the Domestic credit (% of GDP) of Pacific island small states in 2008 to that in 2010?
Your response must be concise. 1.04. What is the ratio of the Domestic credit (% of GDP) of Congo (Republic) in 2008 to that in 2010?
Your response must be concise. 0.48. What is the ratio of the Domestic credit (% of GDP) in Mozambique in 2008 to that in 2010?
Your answer should be compact. 0.65. What is the ratio of the Domestic credit (% of GDP) of Pacific island small states in 2008 to that in 2011?
Offer a very short reply. 1.11. What is the ratio of the Domestic credit (% of GDP) in Congo (Republic) in 2008 to that in 2011?
Give a very brief answer. 0.4. What is the ratio of the Domestic credit (% of GDP) in Mozambique in 2008 to that in 2011?
Offer a terse response. 0.68. What is the ratio of the Domestic credit (% of GDP) in Panama in 2008 to that in 2011?
Provide a succinct answer. 0.99. What is the ratio of the Domestic credit (% of GDP) in Pacific island small states in 2008 to that in 2012?
Your answer should be compact. 1.12. What is the ratio of the Domestic credit (% of GDP) in Congo (Republic) in 2008 to that in 2012?
Provide a short and direct response. 0.33. What is the ratio of the Domestic credit (% of GDP) of Mozambique in 2008 to that in 2012?
Your answer should be very brief. 0.64. What is the ratio of the Domestic credit (% of GDP) in Panama in 2008 to that in 2012?
Provide a succinct answer. 0.98. What is the ratio of the Domestic credit (% of GDP) of Pacific island small states in 2008 to that in 2013?
Keep it short and to the point. 1.11. What is the ratio of the Domestic credit (% of GDP) in Congo (Republic) in 2008 to that in 2013?
Your answer should be compact. 0.28. What is the ratio of the Domestic credit (% of GDP) in Mozambique in 2008 to that in 2013?
Your answer should be compact. 0.56. What is the ratio of the Domestic credit (% of GDP) of Panama in 2008 to that in 2013?
Provide a short and direct response. 1.21. What is the ratio of the Domestic credit (% of GDP) in Pacific island small states in 2008 to that in 2014?
Your answer should be very brief. 1.05. What is the ratio of the Domestic credit (% of GDP) of Congo (Republic) in 2008 to that in 2014?
Offer a terse response. 0.22. What is the ratio of the Domestic credit (% of GDP) in Mozambique in 2008 to that in 2014?
Keep it short and to the point. 0.5. What is the ratio of the Domestic credit (% of GDP) of Panama in 2008 to that in 2014?
Make the answer very short. 0.95. What is the ratio of the Domestic credit (% of GDP) in Pacific island small states in 2009 to that in 2010?
Your response must be concise. 1.04. What is the ratio of the Domestic credit (% of GDP) of Congo (Republic) in 2009 to that in 2010?
Offer a very short reply. 0.75. What is the ratio of the Domestic credit (% of GDP) in Mozambique in 2009 to that in 2010?
Your answer should be compact. 0.9. What is the ratio of the Domestic credit (% of GDP) in Panama in 2009 to that in 2010?
Give a very brief answer. 0.97. What is the ratio of the Domestic credit (% of GDP) of Pacific island small states in 2009 to that in 2011?
Keep it short and to the point. 1.12. What is the ratio of the Domestic credit (% of GDP) in Congo (Republic) in 2009 to that in 2011?
Your answer should be very brief. 0.63. What is the ratio of the Domestic credit (% of GDP) of Mozambique in 2009 to that in 2011?
Offer a terse response. 0.95. What is the ratio of the Domestic credit (% of GDP) of Panama in 2009 to that in 2011?
Offer a terse response. 0.97. What is the ratio of the Domestic credit (% of GDP) of Pacific island small states in 2009 to that in 2012?
Your response must be concise. 1.12. What is the ratio of the Domestic credit (% of GDP) of Congo (Republic) in 2009 to that in 2012?
Your answer should be very brief. 0.51. What is the ratio of the Domestic credit (% of GDP) of Mozambique in 2009 to that in 2012?
Offer a very short reply. 0.9. What is the ratio of the Domestic credit (% of GDP) in Panama in 2009 to that in 2012?
Your answer should be compact. 0.96. What is the ratio of the Domestic credit (% of GDP) of Pacific island small states in 2009 to that in 2013?
Offer a very short reply. 1.11. What is the ratio of the Domestic credit (% of GDP) of Congo (Republic) in 2009 to that in 2013?
Ensure brevity in your answer.  0.43. What is the ratio of the Domestic credit (% of GDP) of Mozambique in 2009 to that in 2013?
Provide a short and direct response. 0.78. What is the ratio of the Domestic credit (% of GDP) of Panama in 2009 to that in 2013?
Offer a very short reply. 1.18. What is the ratio of the Domestic credit (% of GDP) of Pacific island small states in 2009 to that in 2014?
Your answer should be compact. 1.06. What is the ratio of the Domestic credit (% of GDP) in Congo (Republic) in 2009 to that in 2014?
Keep it short and to the point. 0.35. What is the ratio of the Domestic credit (% of GDP) of Mozambique in 2009 to that in 2014?
Your answer should be very brief. 0.69. What is the ratio of the Domestic credit (% of GDP) in Panama in 2009 to that in 2014?
Your answer should be very brief. 0.92. What is the ratio of the Domestic credit (% of GDP) of Pacific island small states in 2010 to that in 2011?
Your answer should be very brief. 1.07. What is the ratio of the Domestic credit (% of GDP) in Congo (Republic) in 2010 to that in 2011?
Provide a succinct answer. 0.84. What is the ratio of the Domestic credit (% of GDP) in Mozambique in 2010 to that in 2011?
Offer a terse response. 1.05. What is the ratio of the Domestic credit (% of GDP) in Panama in 2010 to that in 2011?
Provide a succinct answer. 1. What is the ratio of the Domestic credit (% of GDP) in Pacific island small states in 2010 to that in 2012?
Provide a succinct answer. 1.08. What is the ratio of the Domestic credit (% of GDP) of Congo (Republic) in 2010 to that in 2012?
Give a very brief answer. 0.68. What is the ratio of the Domestic credit (% of GDP) in Panama in 2010 to that in 2012?
Provide a succinct answer. 0.98. What is the ratio of the Domestic credit (% of GDP) of Pacific island small states in 2010 to that in 2013?
Offer a terse response. 1.07. What is the ratio of the Domestic credit (% of GDP) of Congo (Republic) in 2010 to that in 2013?
Give a very brief answer. 0.58. What is the ratio of the Domestic credit (% of GDP) in Mozambique in 2010 to that in 2013?
Your response must be concise. 0.87. What is the ratio of the Domestic credit (% of GDP) of Panama in 2010 to that in 2013?
Your answer should be very brief. 1.22. What is the ratio of the Domestic credit (% of GDP) of Pacific island small states in 2010 to that in 2014?
Offer a terse response. 1.02. What is the ratio of the Domestic credit (% of GDP) in Congo (Republic) in 2010 to that in 2014?
Make the answer very short. 0.46. What is the ratio of the Domestic credit (% of GDP) in Mozambique in 2010 to that in 2014?
Provide a short and direct response. 0.77. What is the ratio of the Domestic credit (% of GDP) in Panama in 2010 to that in 2014?
Your response must be concise. 0.95. What is the ratio of the Domestic credit (% of GDP) of Pacific island small states in 2011 to that in 2012?
Provide a succinct answer. 1.01. What is the ratio of the Domestic credit (% of GDP) of Congo (Republic) in 2011 to that in 2012?
Your response must be concise. 0.81. What is the ratio of the Domestic credit (% of GDP) in Mozambique in 2011 to that in 2012?
Your answer should be compact. 0.95. What is the ratio of the Domestic credit (% of GDP) of Panama in 2011 to that in 2012?
Your response must be concise. 0.99. What is the ratio of the Domestic credit (% of GDP) in Pacific island small states in 2011 to that in 2013?
Provide a succinct answer. 0.99. What is the ratio of the Domestic credit (% of GDP) in Congo (Republic) in 2011 to that in 2013?
Provide a succinct answer. 0.69. What is the ratio of the Domestic credit (% of GDP) of Mozambique in 2011 to that in 2013?
Your answer should be very brief. 0.83. What is the ratio of the Domestic credit (% of GDP) in Panama in 2011 to that in 2013?
Your answer should be compact. 1.22. What is the ratio of the Domestic credit (% of GDP) of Pacific island small states in 2011 to that in 2014?
Make the answer very short. 0.95. What is the ratio of the Domestic credit (% of GDP) in Congo (Republic) in 2011 to that in 2014?
Provide a succinct answer. 0.55. What is the ratio of the Domestic credit (% of GDP) in Mozambique in 2011 to that in 2014?
Your answer should be very brief. 0.73. What is the ratio of the Domestic credit (% of GDP) in Panama in 2011 to that in 2014?
Provide a succinct answer. 0.96. What is the ratio of the Domestic credit (% of GDP) in Pacific island small states in 2012 to that in 2013?
Ensure brevity in your answer.  0.99. What is the ratio of the Domestic credit (% of GDP) of Congo (Republic) in 2012 to that in 2013?
Your answer should be compact. 0.85. What is the ratio of the Domestic credit (% of GDP) of Mozambique in 2012 to that in 2013?
Provide a succinct answer. 0.87. What is the ratio of the Domestic credit (% of GDP) of Panama in 2012 to that in 2013?
Your response must be concise. 1.24. What is the ratio of the Domestic credit (% of GDP) in Pacific island small states in 2012 to that in 2014?
Make the answer very short. 0.94. What is the ratio of the Domestic credit (% of GDP) of Congo (Republic) in 2012 to that in 2014?
Offer a very short reply. 0.68. What is the ratio of the Domestic credit (% of GDP) in Mozambique in 2012 to that in 2014?
Keep it short and to the point. 0.77. What is the ratio of the Domestic credit (% of GDP) of Panama in 2012 to that in 2014?
Offer a terse response. 0.97. What is the ratio of the Domestic credit (% of GDP) in Pacific island small states in 2013 to that in 2014?
Your answer should be very brief. 0.95. What is the ratio of the Domestic credit (% of GDP) in Congo (Republic) in 2013 to that in 2014?
Give a very brief answer. 0.8. What is the ratio of the Domestic credit (% of GDP) of Mozambique in 2013 to that in 2014?
Your answer should be compact. 0.89. What is the ratio of the Domestic credit (% of GDP) in Panama in 2013 to that in 2014?
Ensure brevity in your answer.  0.78. What is the difference between the highest and the second highest Domestic credit (% of GDP) in Pacific island small states?
Your response must be concise. 0.14. What is the difference between the highest and the second highest Domestic credit (% of GDP) of Congo (Republic)?
Offer a terse response. 2.76. What is the difference between the highest and the second highest Domestic credit (% of GDP) in Mozambique?
Ensure brevity in your answer.  3.54. What is the difference between the highest and the second highest Domestic credit (% of GDP) of Panama?
Provide a short and direct response. 2.69. What is the difference between the highest and the lowest Domestic credit (% of GDP) in Pacific island small states?
Keep it short and to the point. 6.07. What is the difference between the highest and the lowest Domestic credit (% of GDP) in Congo (Republic)?
Your response must be concise. 10.91. What is the difference between the highest and the lowest Domestic credit (% of GDP) in Mozambique?
Offer a very short reply. 15.85. What is the difference between the highest and the lowest Domestic credit (% of GDP) of Panama?
Provide a succinct answer. 17.87. 